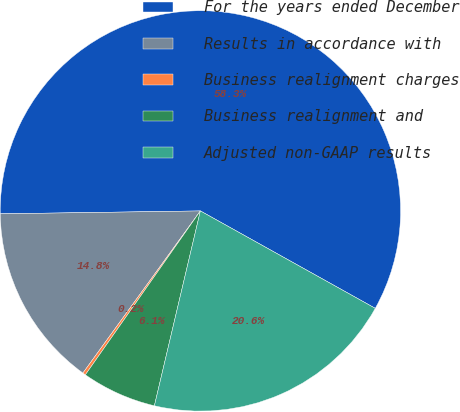Convert chart. <chart><loc_0><loc_0><loc_500><loc_500><pie_chart><fcel>For the years ended December<fcel>Results in accordance with<fcel>Business realignment charges<fcel>Business realignment and<fcel>Adjusted non-GAAP results<nl><fcel>58.32%<fcel>14.79%<fcel>0.24%<fcel>6.05%<fcel>20.6%<nl></chart> 